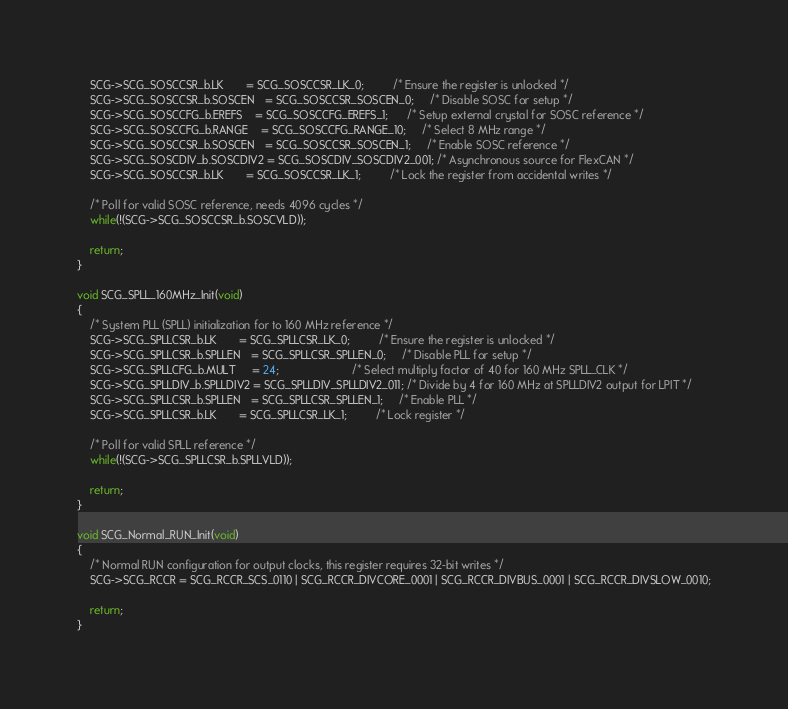Convert code to text. <code><loc_0><loc_0><loc_500><loc_500><_C_>    SCG->SCG_SOSCCSR_b.LK       = SCG_SOSCCSR_LK_0;         /* Ensure the register is unlocked */
    SCG->SCG_SOSCCSR_b.SOSCEN   = SCG_SOSCCSR_SOSCEN_0;     /* Disable SOSC for setup */
    SCG->SCG_SOSCCFG_b.EREFS    = SCG_SOSCCFG_EREFS_1;      /* Setup external crystal for SOSC reference */
    SCG->SCG_SOSCCFG_b.RANGE    = SCG_SOSCCFG_RANGE_10;     /* Select 8 MHz range */
    SCG->SCG_SOSCCSR_b.SOSCEN   = SCG_SOSCCSR_SOSCEN_1;     /* Enable SOSC reference */
    SCG->SCG_SOSCDIV_b.SOSCDIV2 = SCG_SOSCDIV_SOSCDIV2_001; /* Asynchronous source for FlexCAN */
    SCG->SCG_SOSCCSR_b.LK       = SCG_SOSCCSR_LK_1;         /* Lock the register from accidental writes */

    /* Poll for valid SOSC reference, needs 4096 cycles */
    while(!(SCG->SCG_SOSCCSR_b.SOSCVLD));

    return;
}

void SCG_SPLL_160MHz_Init(void)
{
    /* System PLL (SPLL) initialization for to 160 MHz reference */
    SCG->SCG_SPLLCSR_b.LK       = SCG_SPLLCSR_LK_0;         /* Ensure the register is unlocked */
    SCG->SCG_SPLLCSR_b.SPLLEN   = SCG_SPLLCSR_SPLLEN_0;     /* Disable PLL for setup */
    SCG->SCG_SPLLCFG_b.MULT     = 24;                       /* Select multiply factor of 40 for 160 MHz SPLL_CLK */
    SCG->SCG_SPLLDIV_b.SPLLDIV2 = SCG_SPLLDIV_SPLLDIV2_011; /* Divide by 4 for 160 MHz at SPLLDIV2 output for LPIT */
    SCG->SCG_SPLLCSR_b.SPLLEN   = SCG_SPLLCSR_SPLLEN_1;     /* Enable PLL */
    SCG->SCG_SPLLCSR_b.LK       = SCG_SPLLCSR_LK_1;         /* Lock register */

    /* Poll for valid SPLL reference */
    while(!(SCG->SCG_SPLLCSR_b.SPLLVLD));

    return;
}

void SCG_Normal_RUN_Init(void)
{
    /* Normal RUN configuration for output clocks, this register requires 32-bit writes */
    SCG->SCG_RCCR = SCG_RCCR_SCS_0110 | SCG_RCCR_DIVCORE_0001 | SCG_RCCR_DIVBUS_0001 | SCG_RCCR_DIVSLOW_0010;

    return;
}
</code> 